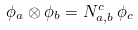Convert formula to latex. <formula><loc_0><loc_0><loc_500><loc_500>\phi _ { a } \otimes \phi _ { b } = N _ { a , b } ^ { c } \, \phi _ { c }</formula> 